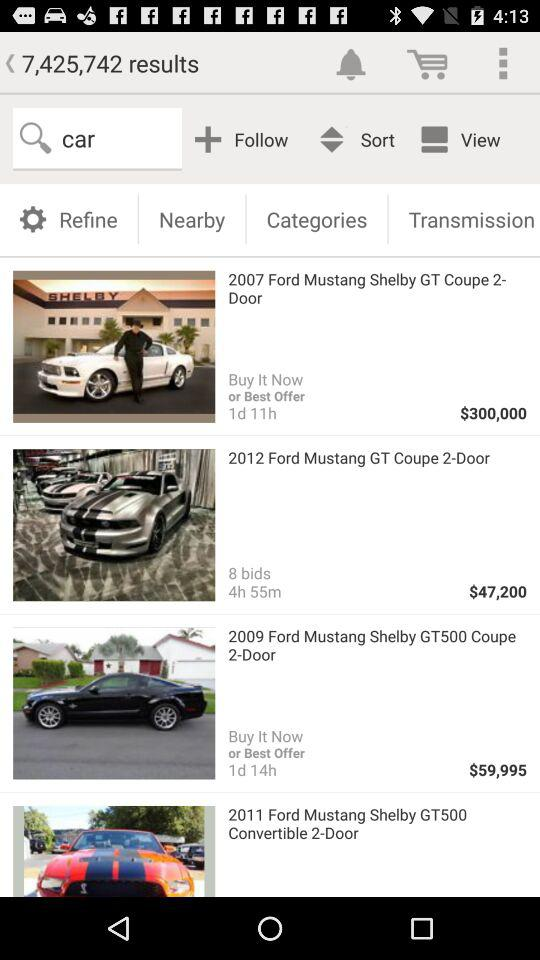What is the name of the car that costs $300,000? The name of the car that costs $300,000 is the "2007 Ford Mustang Shelby GT Coupe 2- Door". 